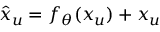<formula> <loc_0><loc_0><loc_500><loc_500>\hat { x } _ { u } = f _ { \theta } ( x _ { u } ) + x _ { u }</formula> 